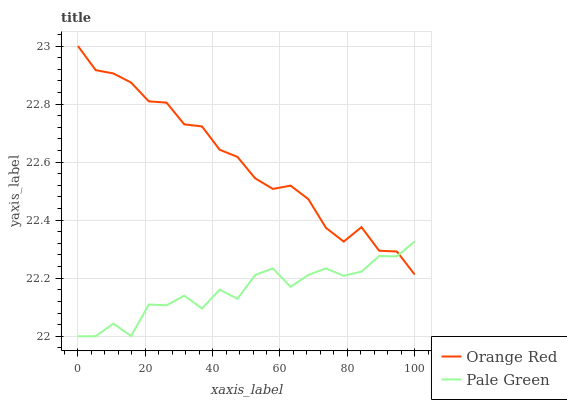Does Pale Green have the minimum area under the curve?
Answer yes or no. Yes. Does Orange Red have the maximum area under the curve?
Answer yes or no. Yes. Does Orange Red have the minimum area under the curve?
Answer yes or no. No. Is Orange Red the smoothest?
Answer yes or no. Yes. Is Pale Green the roughest?
Answer yes or no. Yes. Is Orange Red the roughest?
Answer yes or no. No. Does Orange Red have the lowest value?
Answer yes or no. No. Does Orange Red have the highest value?
Answer yes or no. Yes. Does Orange Red intersect Pale Green?
Answer yes or no. Yes. Is Orange Red less than Pale Green?
Answer yes or no. No. Is Orange Red greater than Pale Green?
Answer yes or no. No. 